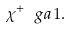Convert formula to latex. <formula><loc_0><loc_0><loc_500><loc_500>\chi ^ { + } \ g a 1 .</formula> 